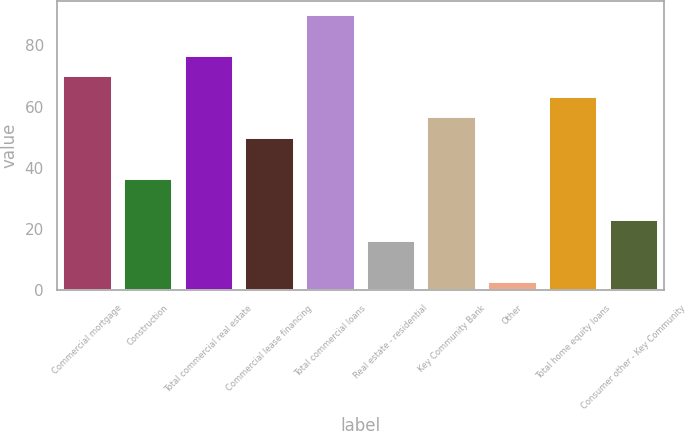Convert chart to OTSL. <chart><loc_0><loc_0><loc_500><loc_500><bar_chart><fcel>Commercial mortgage<fcel>Construction<fcel>Total commercial real estate<fcel>Commercial lease financing<fcel>Total commercial loans<fcel>Real estate - residential<fcel>Key Community Bank<fcel>Other<fcel>Total home equity loans<fcel>Consumer other - Key Community<nl><fcel>69.9<fcel>36.35<fcel>76.61<fcel>49.77<fcel>90.03<fcel>16.22<fcel>56.48<fcel>2.8<fcel>63.19<fcel>22.93<nl></chart> 